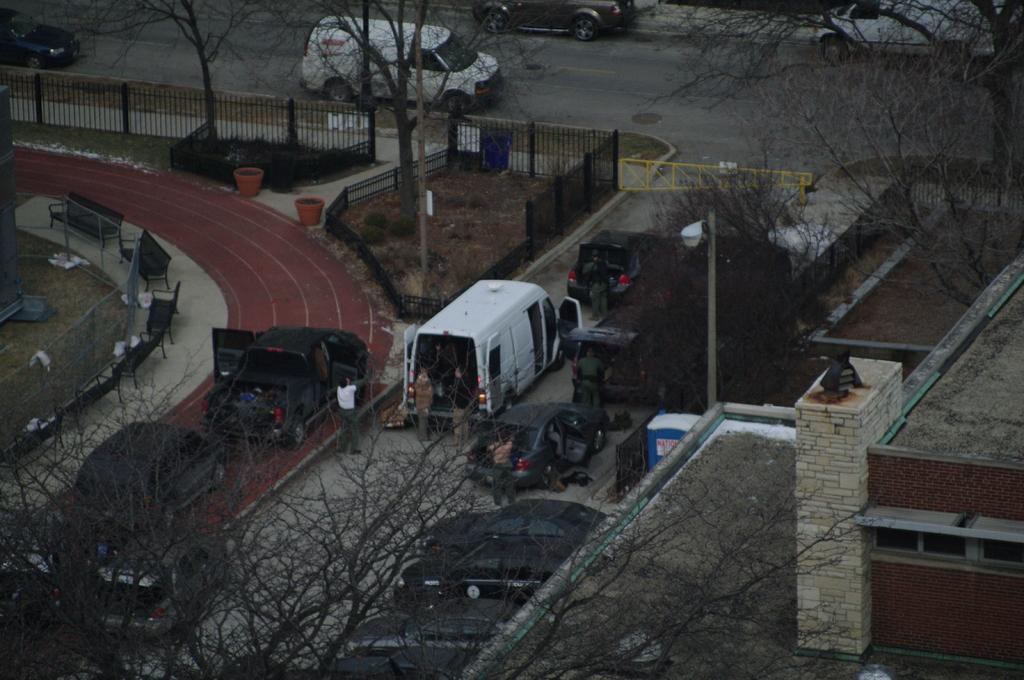Describe this image in one or two sentences. In this picture I can see vehicles, there are group of people standing, there are benches, there is grass, wire fence, pole, light, there are iron grilles and there are trees. 